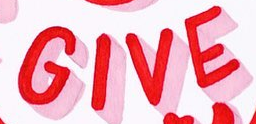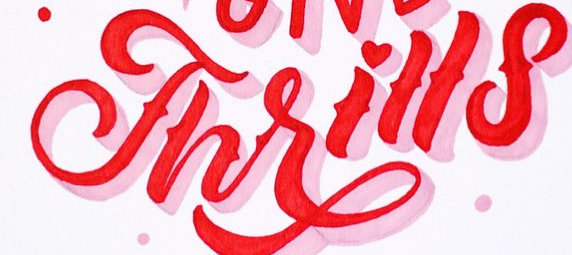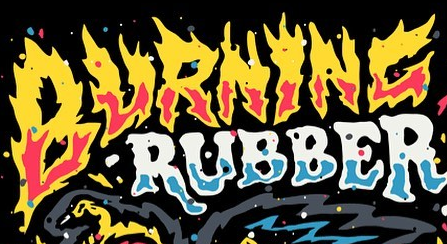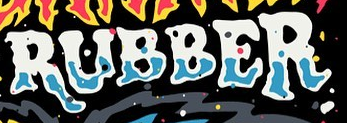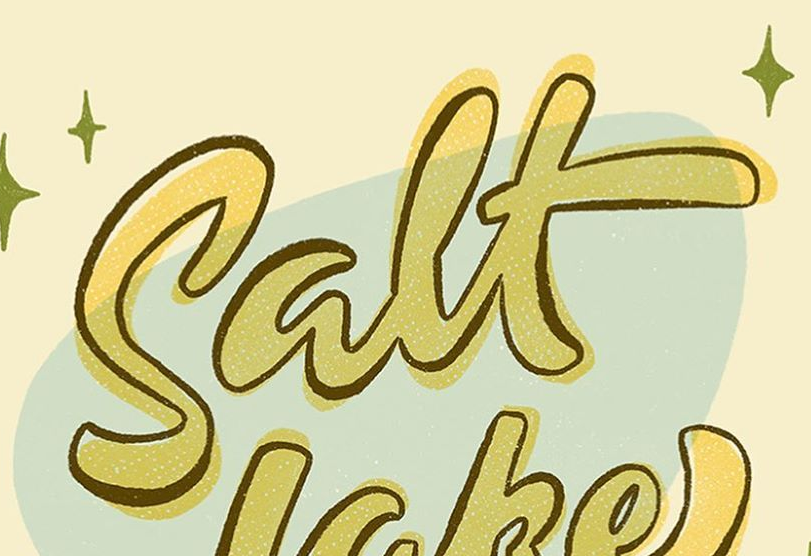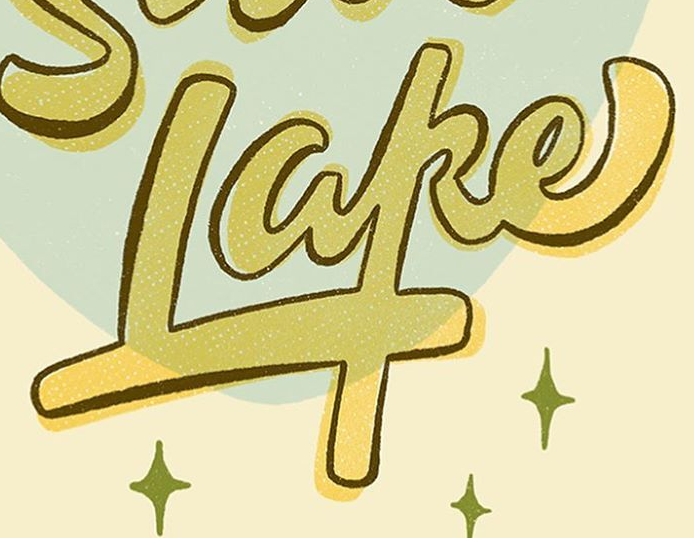What words are shown in these images in order, separated by a semicolon? GIVE; Thrills; BURNINC; RUBBER; Salt; Lake 